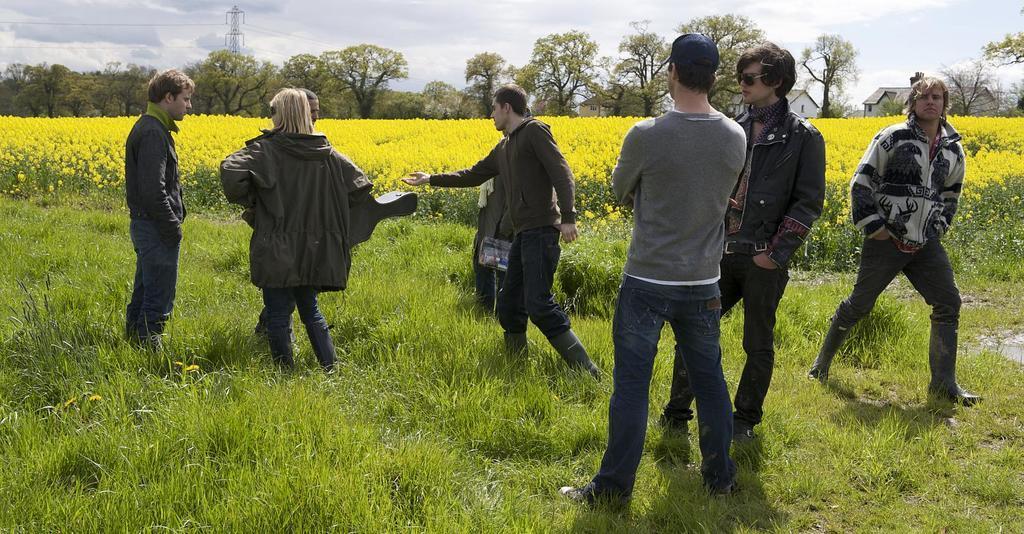Please provide a concise description of this image. At the bottom of the image on the ground there is grass. There are few people standing on the grass. Behind them there are flowers and plants. In the background there are trees, buildings with roofs, walls and windows. And also there is a tower with wires. At the top of the image there is sky. 